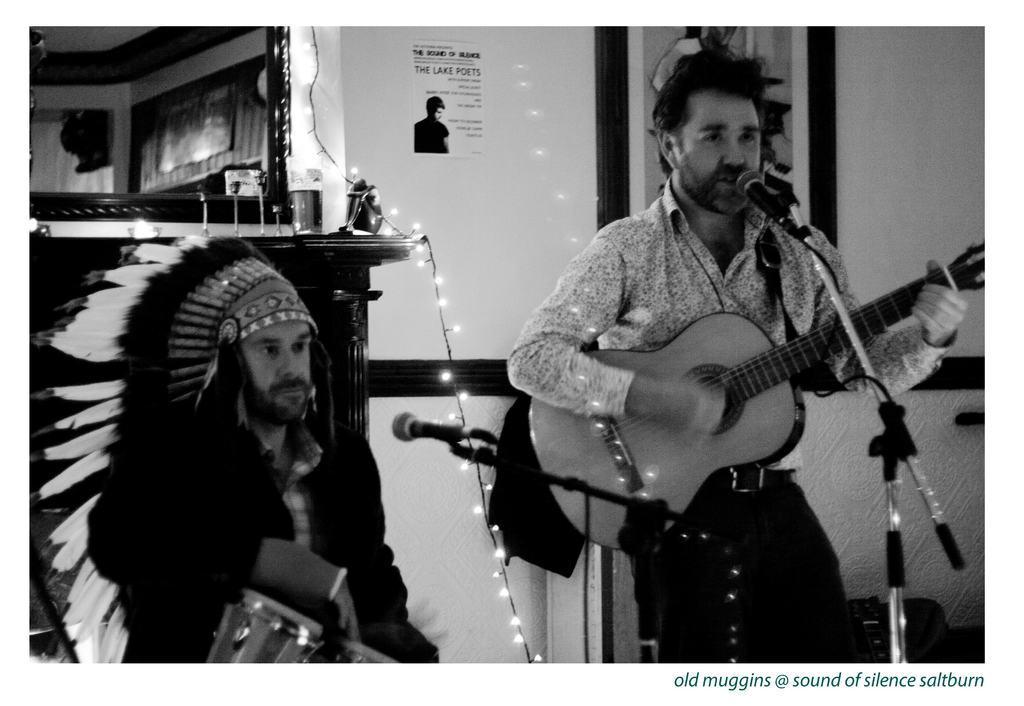How would you summarize this image in a sentence or two? In this picture we can see a photo of photo we have two persons one is in standing position and other one is in sitting position that playing a musical instruments standing person is singing a song at the back we have alighting. 